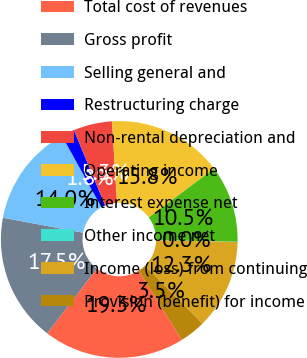<chart> <loc_0><loc_0><loc_500><loc_500><pie_chart><fcel>Total cost of revenues<fcel>Gross profit<fcel>Selling general and<fcel>Restructuring charge<fcel>Non-rental depreciation and<fcel>Operating income<fcel>Interest expense net<fcel>Other income net<fcel>Income (loss) from continuing<fcel>Provision (benefit) for income<nl><fcel>19.27%<fcel>17.52%<fcel>14.02%<fcel>1.78%<fcel>5.28%<fcel>15.77%<fcel>10.52%<fcel>0.03%<fcel>12.27%<fcel>3.53%<nl></chart> 